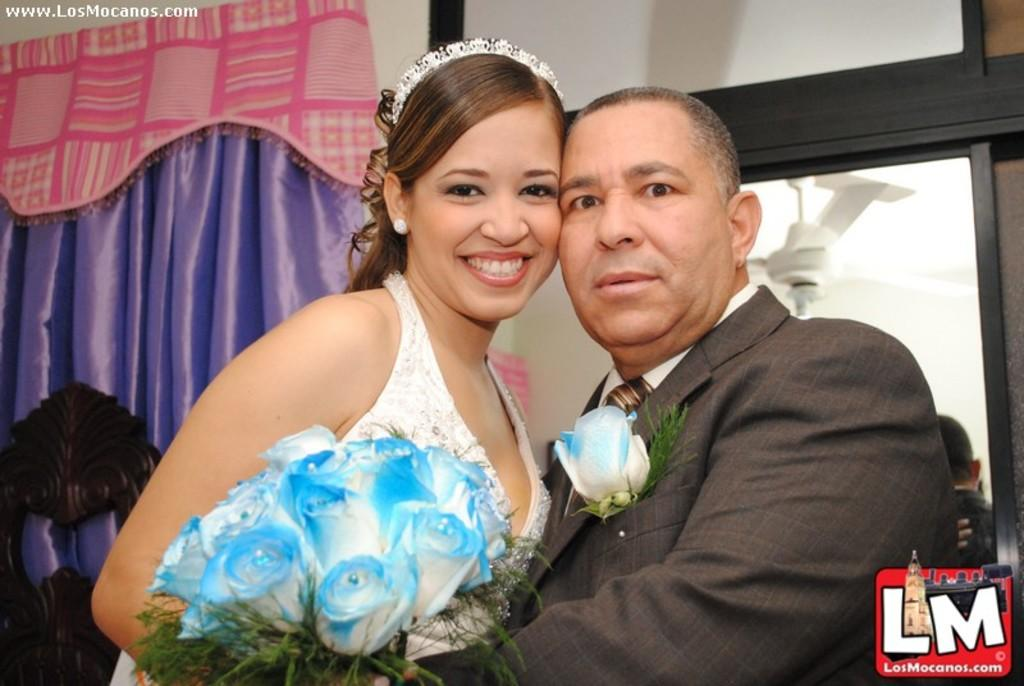What are the two people in the image? There is a man and a woman in the image. What is the woman holding in the image? The woman is holding a bouquet. What can be seen in the background of the image? There is a curtain and a mirror in the background of the image. How many spiders are crawling on the man in the image? There are no spiders visible in the image. What offer is the man making to the woman in the image? The image does not provide any information about an offer being made. 